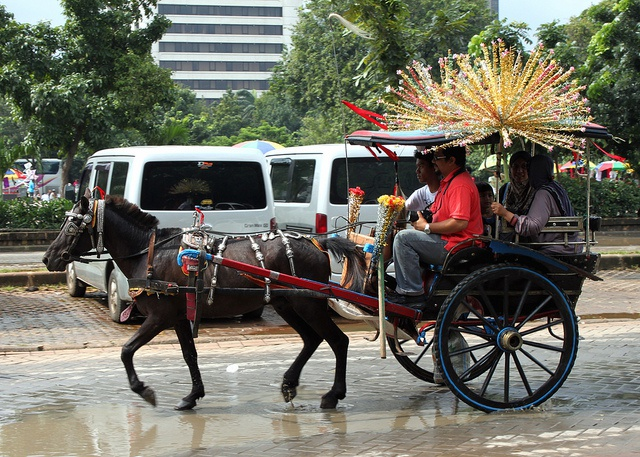Describe the objects in this image and their specific colors. I can see horse in white, black, gray, maroon, and darkgray tones, car in white, black, darkgray, and gray tones, truck in white, black, darkgray, and gray tones, truck in white, black, darkgray, and gray tones, and car in white, black, darkgray, and gray tones in this image. 